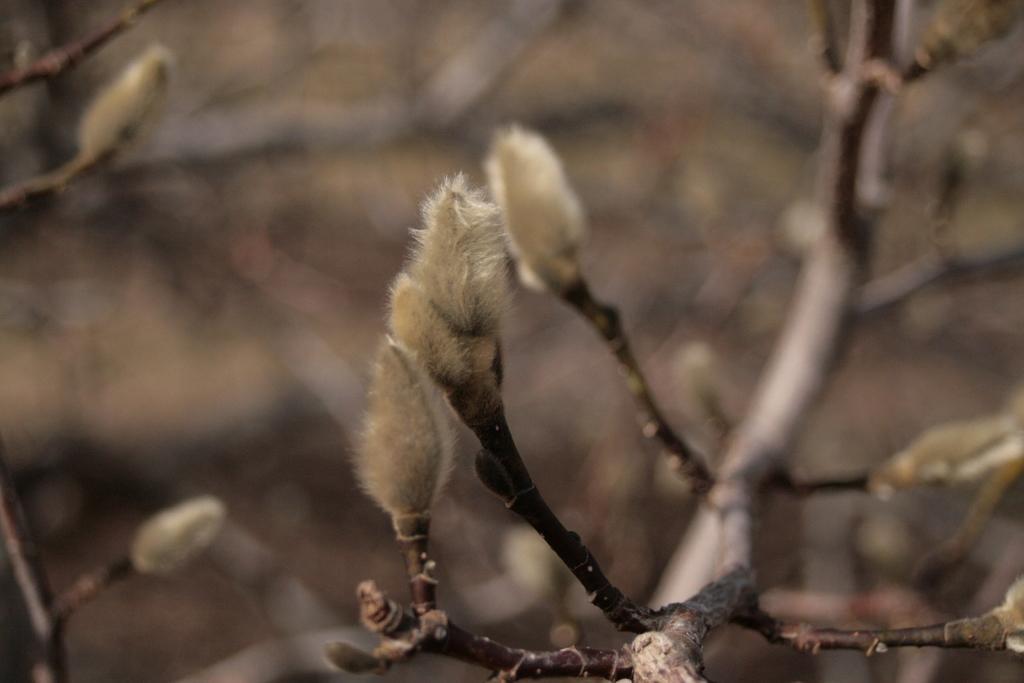How would you summarize this image in a sentence or two? In this picture we can see a plant with buds. Background portion of the picture is blur. 